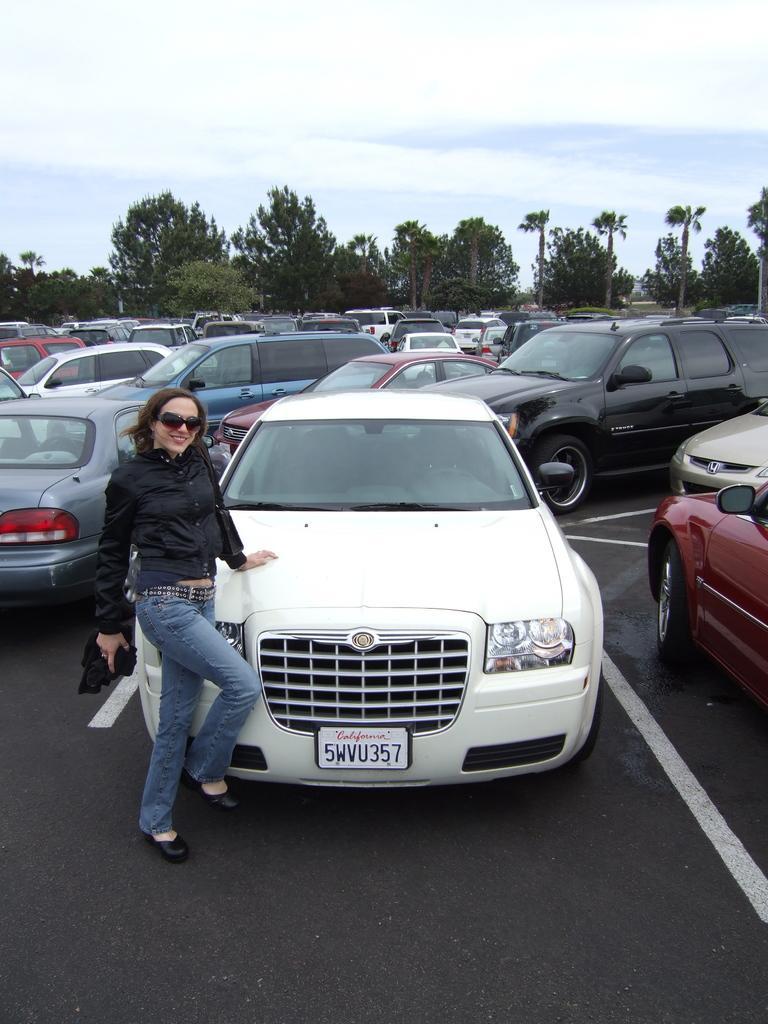Describe this image in one or two sentences. In the image there is a lady standing in front of the car. There are many cars on the road. Behind the cars there are many trees. At the top of the image there is sky. 